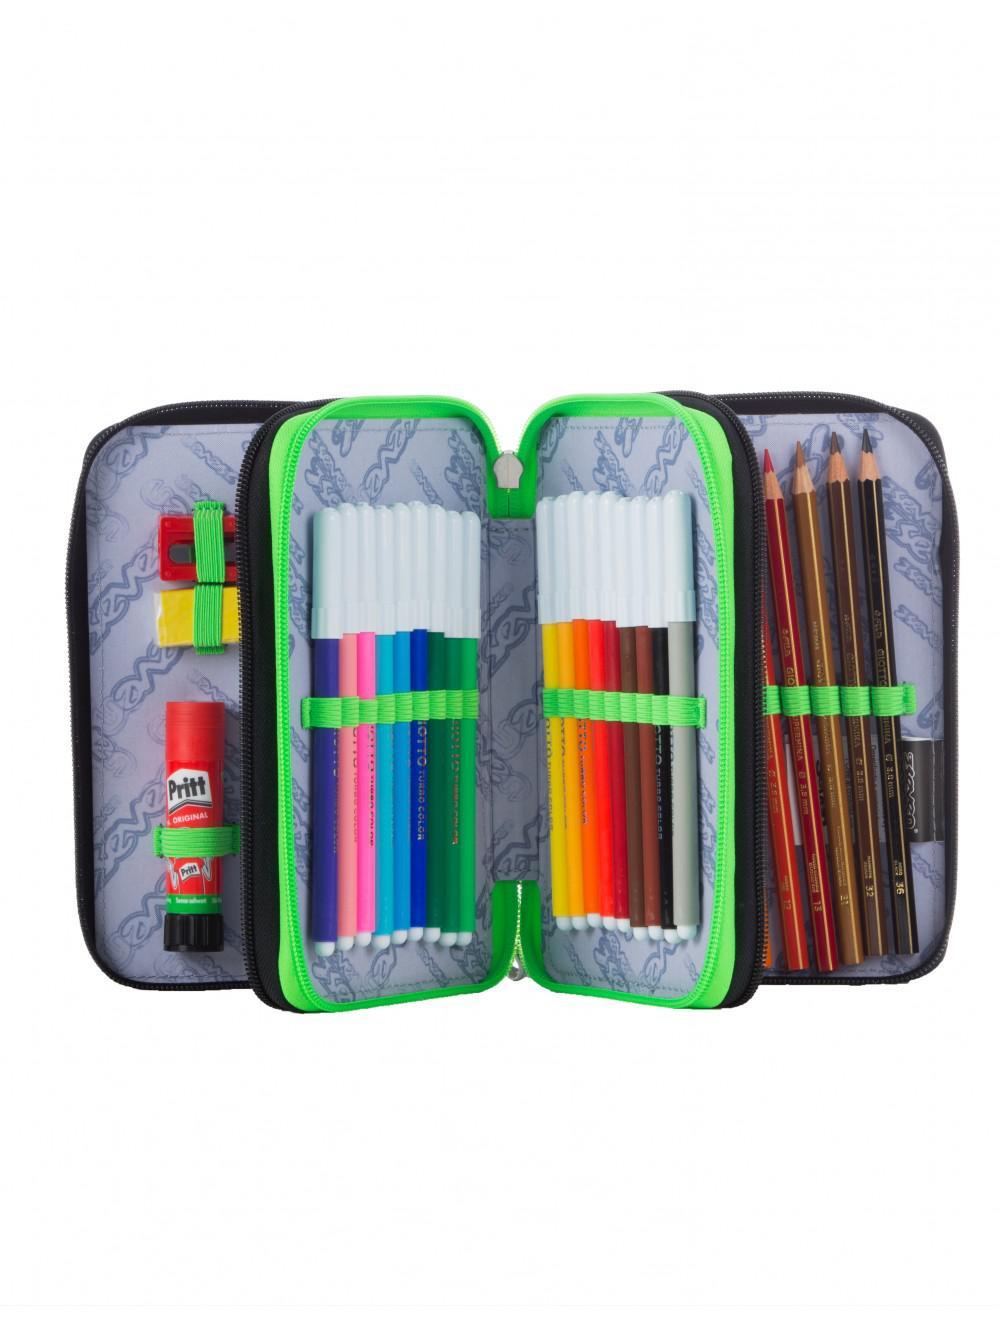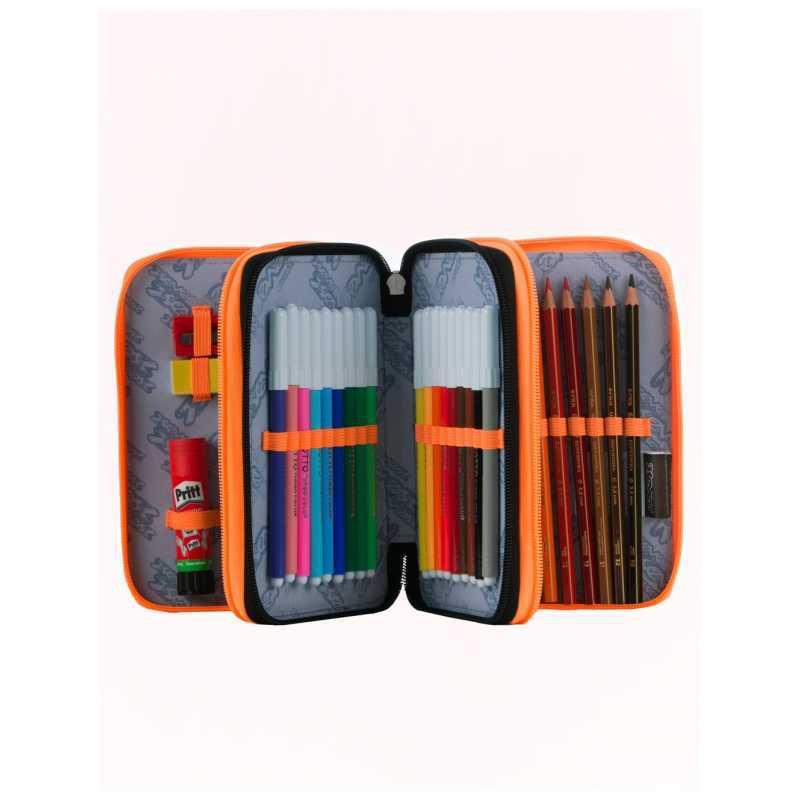The first image is the image on the left, the second image is the image on the right. Assess this claim about the two images: "One image shows a pencil case with a pink interior displayed so its multiple inner compartments fan out.". Correct or not? Answer yes or no. No. The first image is the image on the left, the second image is the image on the right. Evaluate the accuracy of this statement regarding the images: "At least one pencil case has a pink inner lining.". Is it true? Answer yes or no. No. 